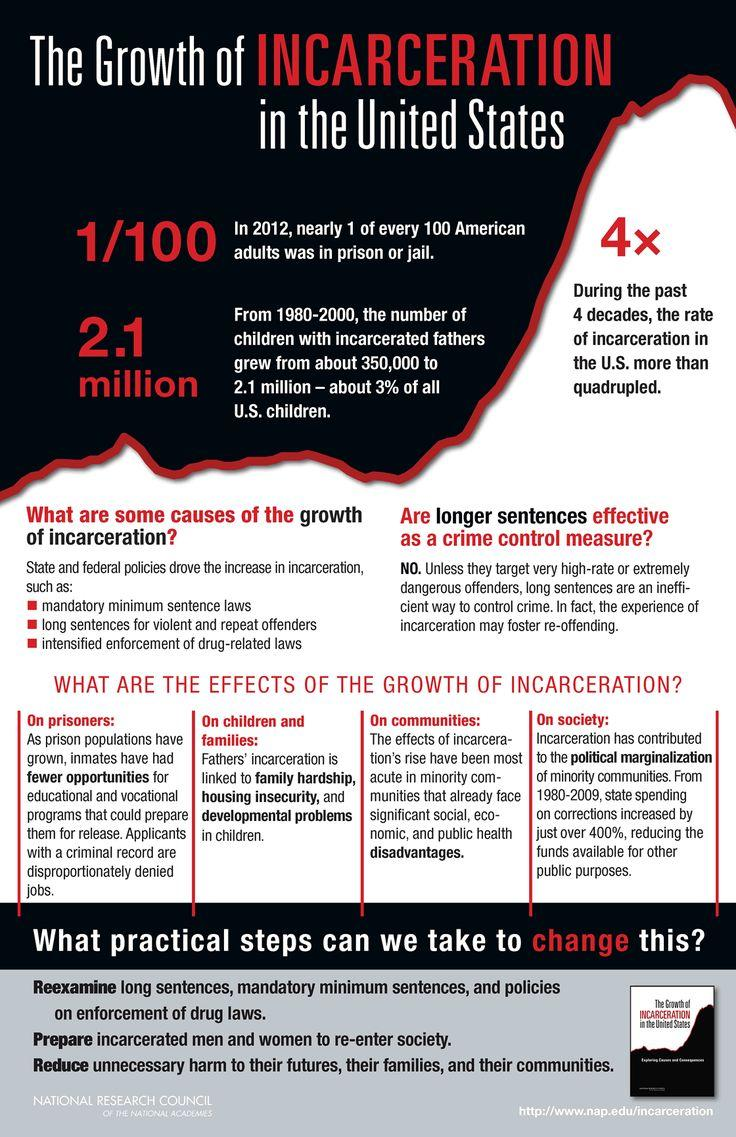List a handful of essential elements in this visual. During the years 1980 to 2000, approximately 2.1 million children in the United States had fathers who were incarcerated. 